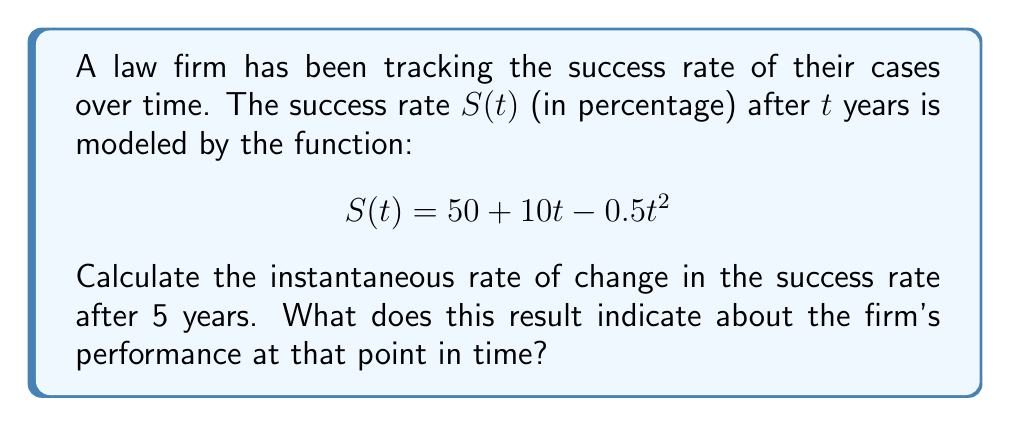Teach me how to tackle this problem. To find the instantaneous rate of change in the success rate after 5 years, we need to calculate the derivative of $S(t)$ and evaluate it at $t=5$.

Step 1: Find the derivative of $S(t)$
$$S(t) = 50 + 10t - 0.5t^2$$
$$S'(t) = 10 - t$$

Step 2: Evaluate $S'(t)$ at $t=5$
$$S'(5) = 10 - 5 = 5$$

The instantaneous rate of change after 5 years is 5 percentage points per year.

Step 3: Interpret the result
A positive rate of change (5) indicates that the success rate is still increasing at the 5-year mark, but at a slower rate than initially. This suggests that while the firm's performance is still improving, the rate of improvement is slowing down.

To provide more context:
- The initial rate of change (at $t=0$) was 10 percentage points per year.
- The rate of change decreases linearly over time due to the negative quadratic term in the original function.
- The success rate will reach its maximum when $S'(t) = 0$, which occurs at $t=10$ years.
Answer: 5 percentage points per year, indicating slowing improvement 